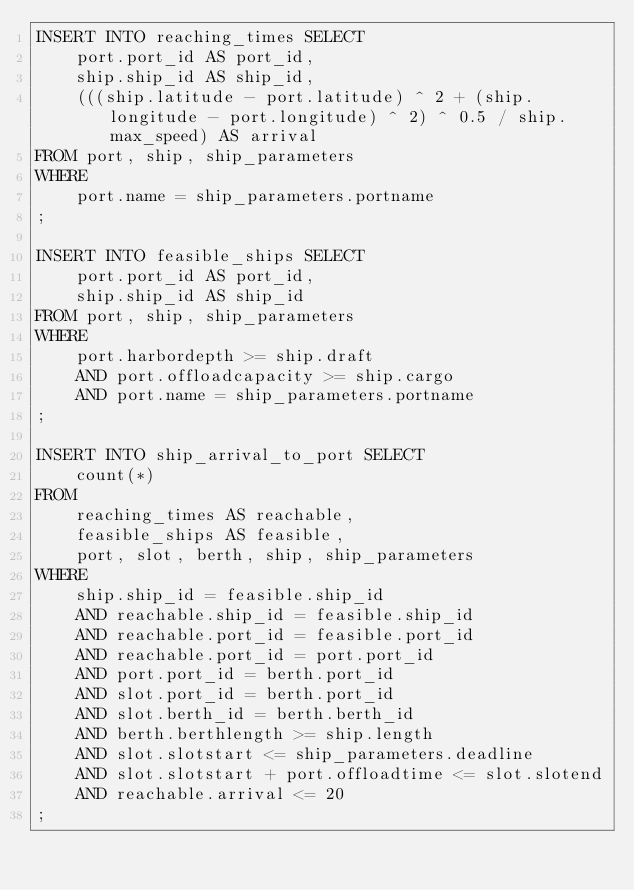<code> <loc_0><loc_0><loc_500><loc_500><_SQL_>INSERT INTO reaching_times SELECT
    port.port_id AS port_id,
    ship.ship_id AS ship_id,
    (((ship.latitude - port.latitude) ^ 2 + (ship.longitude - port.longitude) ^ 2) ^ 0.5 / ship.max_speed) AS arrival
FROM port, ship, ship_parameters
WHERE
    port.name = ship_parameters.portname
;

INSERT INTO feasible_ships SELECT
    port.port_id AS port_id,
    ship.ship_id AS ship_id
FROM port, ship, ship_parameters
WHERE
    port.harbordepth >= ship.draft
    AND port.offloadcapacity >= ship.cargo
    AND port.name = ship_parameters.portname
;

INSERT INTO ship_arrival_to_port SELECT
    count(*)
FROM
    reaching_times AS reachable,
    feasible_ships AS feasible,
    port, slot, berth, ship, ship_parameters
WHERE
    ship.ship_id = feasible.ship_id
    AND reachable.ship_id = feasible.ship_id
    AND reachable.port_id = feasible.port_id
    AND reachable.port_id = port.port_id
    AND port.port_id = berth.port_id
    AND slot.port_id = berth.port_id
    AND slot.berth_id = berth.berth_id
    AND berth.berthlength >= ship.length
    AND slot.slotstart <= ship_parameters.deadline
    AND slot.slotstart + port.offloadtime <= slot.slotend
    AND reachable.arrival <= 20
;
</code> 